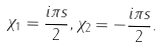Convert formula to latex. <formula><loc_0><loc_0><loc_500><loc_500>\chi _ { 1 } = \frac { i \pi s } { 2 } , \chi _ { 2 } = - \frac { i \pi s } { 2 } .</formula> 